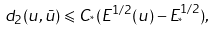Convert formula to latex. <formula><loc_0><loc_0><loc_500><loc_500>d _ { 2 } ( u , \bar { u } ) \leqslant C _ { ^ { * } } ( E ^ { 1 / 2 } ( u ) - E ^ { 1 / 2 } _ { ^ { * } } ) ,</formula> 